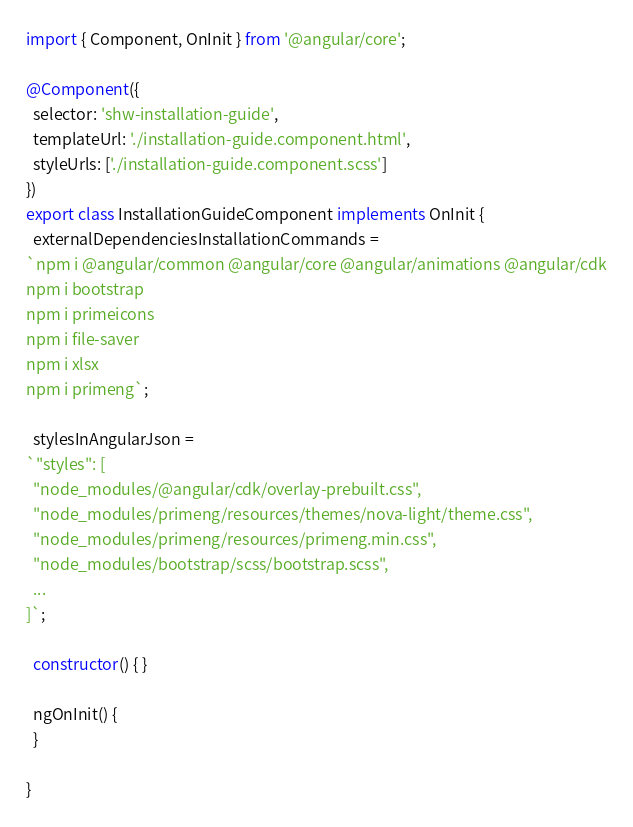<code> <loc_0><loc_0><loc_500><loc_500><_TypeScript_>import { Component, OnInit } from '@angular/core';

@Component({
  selector: 'shw-installation-guide',
  templateUrl: './installation-guide.component.html',
  styleUrls: ['./installation-guide.component.scss']
})
export class InstallationGuideComponent implements OnInit {
  externalDependenciesInstallationCommands =
`npm i @angular/common @angular/core @angular/animations @angular/cdk
npm i bootstrap
npm i primeicons
npm i file-saver
npm i xlsx
npm i primeng`;

  stylesInAngularJson =
`"styles": [
  "node_modules/@angular/cdk/overlay-prebuilt.css",
  "node_modules/primeng/resources/themes/nova-light/theme.css",
  "node_modules/primeng/resources/primeng.min.css",
  "node_modules/bootstrap/scss/bootstrap.scss",
  ...
]`;

  constructor() { }

  ngOnInit() {
  }

}
</code> 